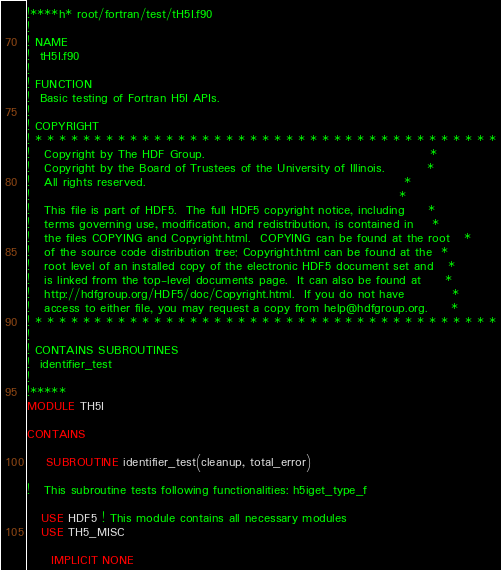Convert code to text. <code><loc_0><loc_0><loc_500><loc_500><_FORTRAN_>!****h* root/fortran/test/tH5I.f90
!
! NAME
!  tH5I.f90
!
! FUNCTION
!  Basic testing of Fortran H5I APIs.
!
! COPYRIGHT
! * * * * * * * * * * * * * * * * * * * * * * * * * * * * * * * * * * * * * * *
!   Copyright by The HDF Group.                                               *
!   Copyright by the Board of Trustees of the University of Illinois.         *
!   All rights reserved.                                                      *
!                                                                             *
!   This file is part of HDF5.  The full HDF5 copyright notice, including     *
!   terms governing use, modification, and redistribution, is contained in    *
!   the files COPYING and Copyright.html.  COPYING can be found at the root   *
!   of the source code distribution tree; Copyright.html can be found at the  *
!   root level of an installed copy of the electronic HDF5 document set and   *
!   is linked from the top-level documents page.  It can also be found at     *
!   http://hdfgroup.org/HDF5/doc/Copyright.html.  If you do not have          *
!   access to either file, you may request a copy from help@hdfgroup.org.     *
! * * * * * * * * * * * * * * * * * * * * * * * * * * * * * * * * * * * * * * *
!
! CONTAINS SUBROUTINES
!  identifier_test
!
!*****
MODULE TH5I

CONTAINS

    SUBROUTINE identifier_test(cleanup, total_error)

!   This subroutine tests following functionalities: h5iget_type_f

   USE HDF5 ! This module contains all necessary modules
   USE TH5_MISC

     IMPLICIT NONE</code> 